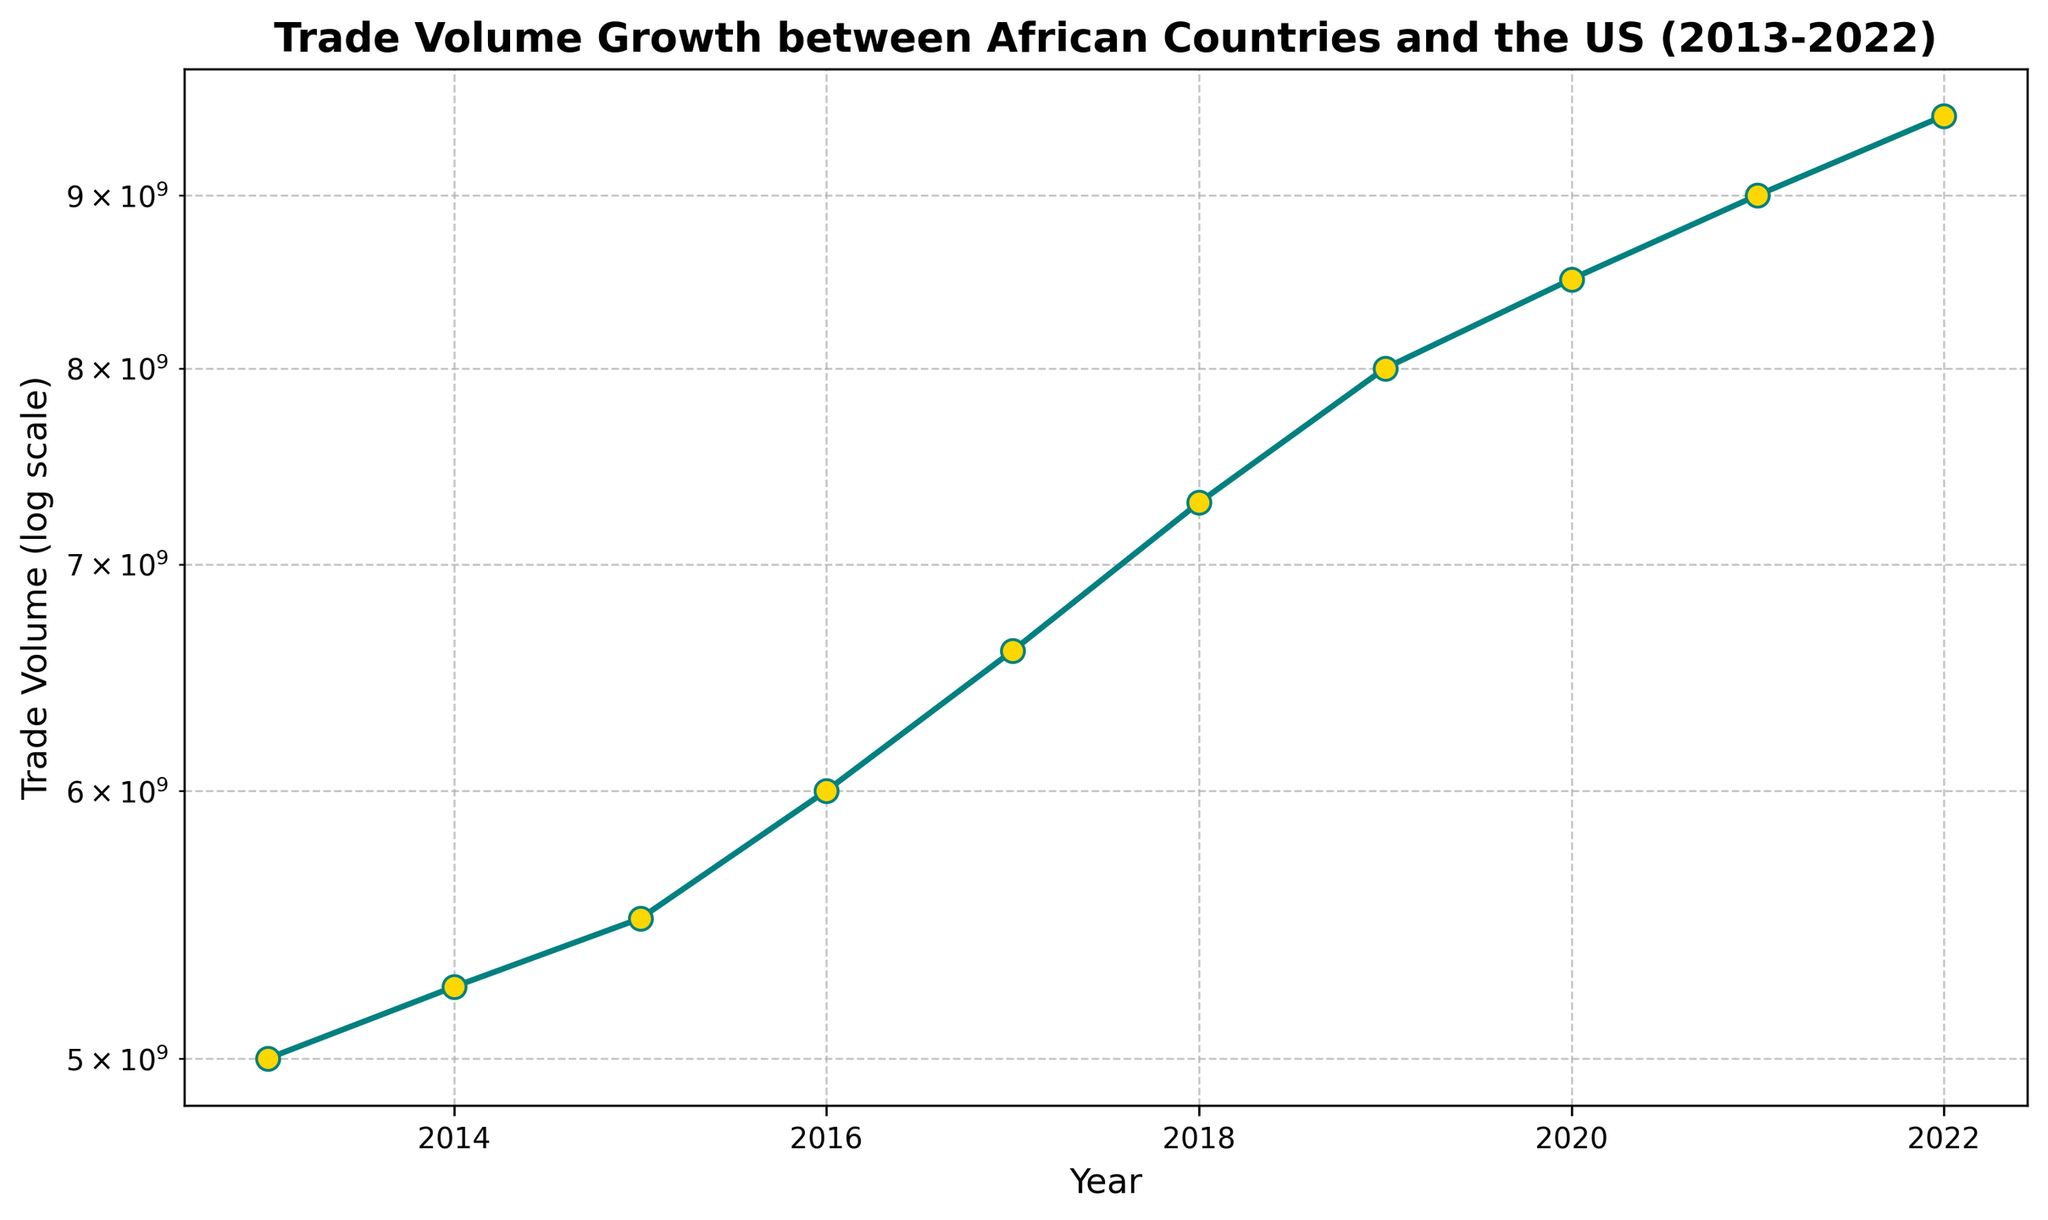Which year had the highest trade volume? The figure shows trade volume growth from 2013 to 2022. By looking at the highest point on the plot, we see that the year 2022 had the highest trade volume.
Answer: 2022 What is the difference in trade volume between 2013 and 2022? From the graph, the trade volume in 2013 is $5 billion and in 2022 is $9.5 billion. The difference is $9.5 billion - $5 billion = $4.5 billion.
Answer: $4.5 billion How does the trade volume in 2018 compare to that in 2015? The graph indicates that the trade volume in 2018 is $7.3 billion, whereas in 2015 it is $5.5 billion. Clearly, $7.3 billion is greater than $5.5 billion.
Answer: The trade volume in 2018 is greater than in 2015 What is the average trade volume over the decade? The trade volumes for 2013-2022 are listed as $5 billion, $5.25 billion, $5.5 billion, $6 billion, $6.6 billion, $7.3 billion, $8 billion, $8.5 billion, $9 billion, and $9.5 billion. Summing these gives $70.65 billion. There are 10 years, so the average is $70.65 billion / 10 = $7.065 billion.
Answer: $7.065 billion In which year did the trade volume first reach $7 billion? According to the graph, the trade volume first exceeds $7 billion in 2018.
Answer: 2018 Between which consecutive years did the trade volume grow the most? Looking at the plot, the biggest jump seems to occur between 2017 ($6.6 billion) and 2018 ($7.3 billion), which is a difference of $0.7 billion. This is larger compared to other consecutive year differences.
Answer: Between 2017 and 2018 What is the median trade volume within the decade? To find the median, list the trade volumes in ascending order: $5 billion, $5.25 billion, $5.5 billion, $6 billion, $6.6 billion, $7.3 billion, $8 billion, $8.5 billion, $9 billion, $9.5 billion. The median, being the middle value of this ordered list, on a 10-item list is the average of the 5th and 6th values, ($6.6 billion + $7.3 billion) / 2 = $6.95 billion.
Answer: $6.95 billion 